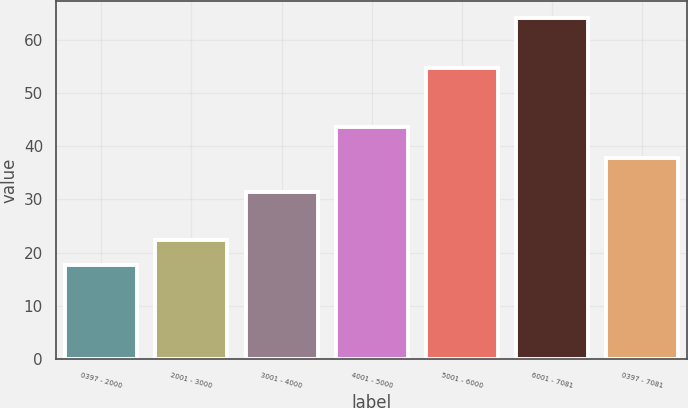<chart> <loc_0><loc_0><loc_500><loc_500><bar_chart><fcel>0397 - 2000<fcel>2001 - 3000<fcel>3001 - 4000<fcel>4001 - 5000<fcel>5001 - 6000<fcel>6001 - 7081<fcel>0397 - 7081<nl><fcel>17.72<fcel>22.36<fcel>31.45<fcel>43.62<fcel>54.81<fcel>64.1<fcel>37.77<nl></chart> 